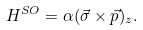Convert formula to latex. <formula><loc_0><loc_0><loc_500><loc_500>H ^ { S O } = \alpha ( \vec { \sigma } \times \vec { p } ) _ { z } .</formula> 